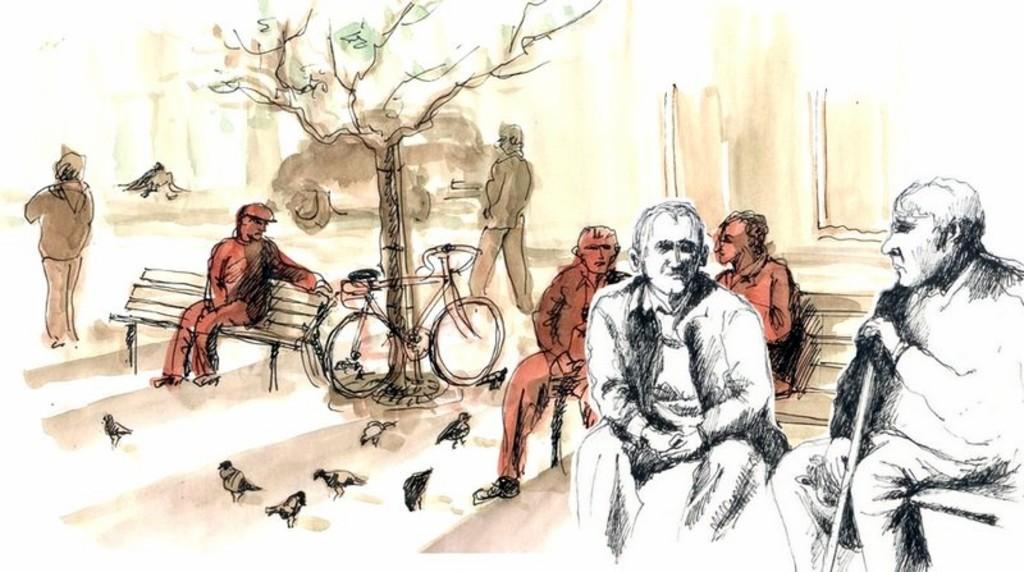What are the people in the image doing? There are persons sitting and standing in the image. What other living creatures can be seen in the image? There are birds in the image. What mode of transportation is present in the image? There is a bicycle in the image. What type of plant is visible in the image? There is a tree in the image. How many lizards are climbing on the tree in the image? There are no lizards present in the image; it only features birds and a tree. What type of pickle is being used as a prop in the image? There is no pickle present in the image. 